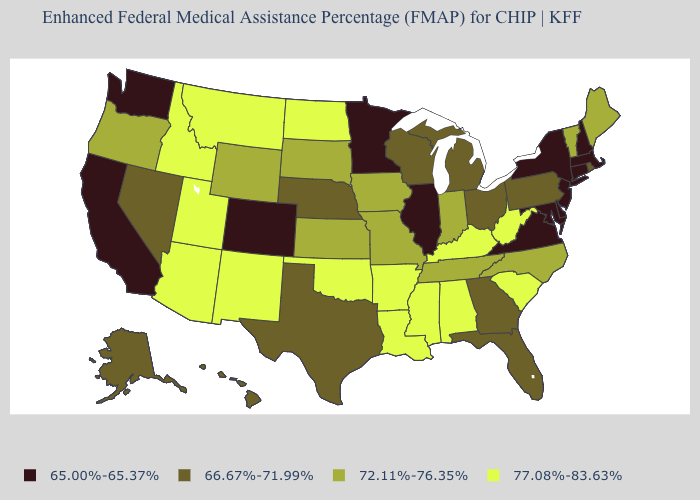Name the states that have a value in the range 77.08%-83.63%?
Concise answer only. Alabama, Arizona, Arkansas, Idaho, Kentucky, Louisiana, Mississippi, Montana, New Mexico, North Dakota, Oklahoma, South Carolina, Utah, West Virginia. What is the value of Rhode Island?
Be succinct. 66.67%-71.99%. Which states have the highest value in the USA?
Short answer required. Alabama, Arizona, Arkansas, Idaho, Kentucky, Louisiana, Mississippi, Montana, New Mexico, North Dakota, Oklahoma, South Carolina, Utah, West Virginia. What is the value of New Mexico?
Short answer required. 77.08%-83.63%. Among the states that border Washington , which have the highest value?
Be succinct. Idaho. What is the value of Washington?
Answer briefly. 65.00%-65.37%. Which states hav the highest value in the Northeast?
Write a very short answer. Maine, Vermont. What is the value of Illinois?
Be succinct. 65.00%-65.37%. Name the states that have a value in the range 77.08%-83.63%?
Concise answer only. Alabama, Arizona, Arkansas, Idaho, Kentucky, Louisiana, Mississippi, Montana, New Mexico, North Dakota, Oklahoma, South Carolina, Utah, West Virginia. What is the value of Iowa?
Be succinct. 72.11%-76.35%. Name the states that have a value in the range 66.67%-71.99%?
Be succinct. Alaska, Florida, Georgia, Hawaii, Michigan, Nebraska, Nevada, Ohio, Pennsylvania, Rhode Island, Texas, Wisconsin. Name the states that have a value in the range 72.11%-76.35%?
Write a very short answer. Indiana, Iowa, Kansas, Maine, Missouri, North Carolina, Oregon, South Dakota, Tennessee, Vermont, Wyoming. What is the highest value in states that border Pennsylvania?
Quick response, please. 77.08%-83.63%. Does Connecticut have the highest value in the Northeast?
Short answer required. No. Name the states that have a value in the range 72.11%-76.35%?
Short answer required. Indiana, Iowa, Kansas, Maine, Missouri, North Carolina, Oregon, South Dakota, Tennessee, Vermont, Wyoming. 